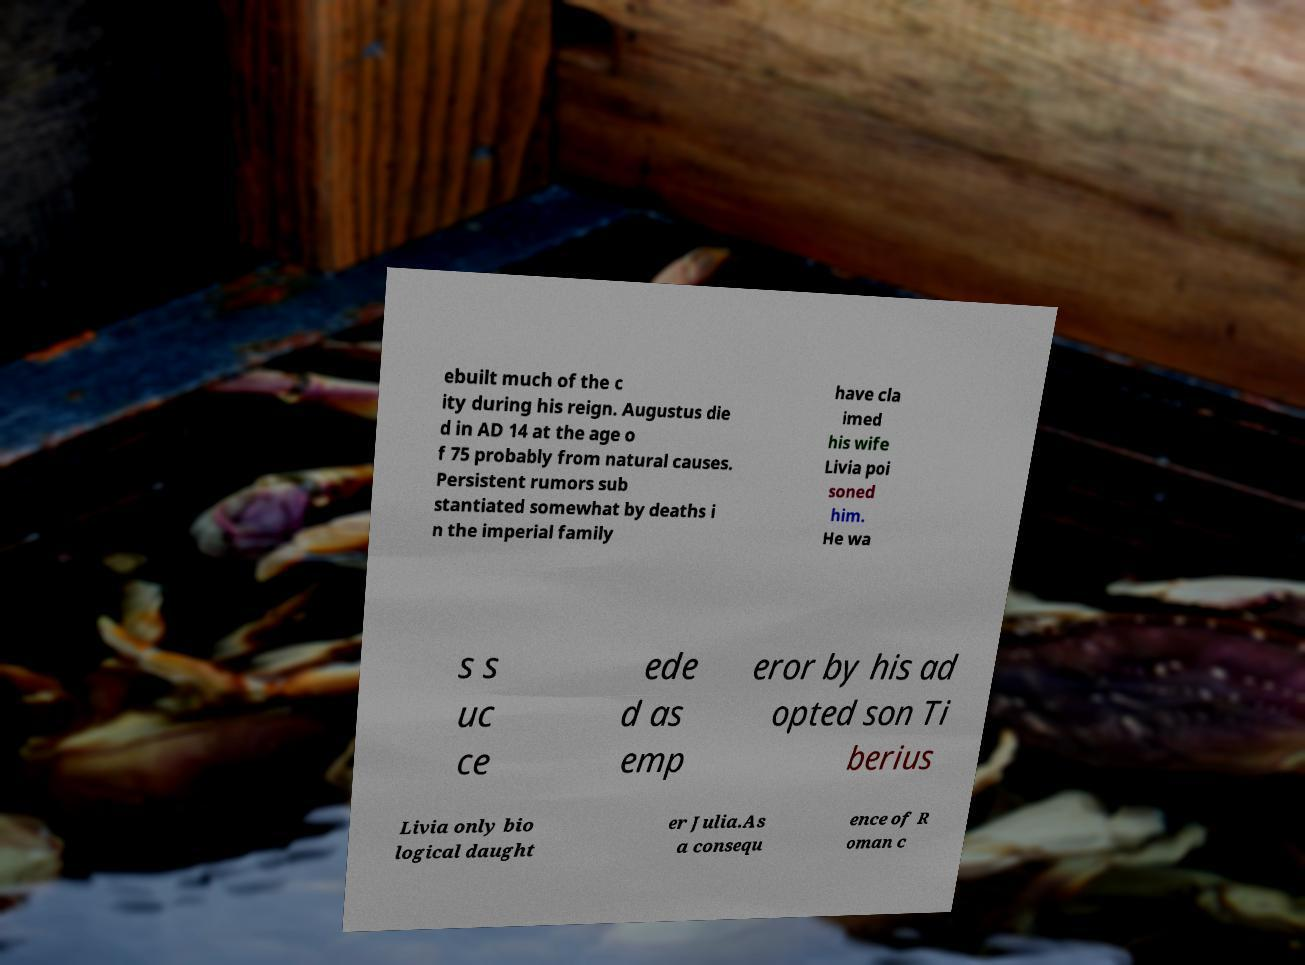For documentation purposes, I need the text within this image transcribed. Could you provide that? ebuilt much of the c ity during his reign. Augustus die d in AD 14 at the age o f 75 probably from natural causes. Persistent rumors sub stantiated somewhat by deaths i n the imperial family have cla imed his wife Livia poi soned him. He wa s s uc ce ede d as emp eror by his ad opted son Ti berius Livia only bio logical daught er Julia.As a consequ ence of R oman c 